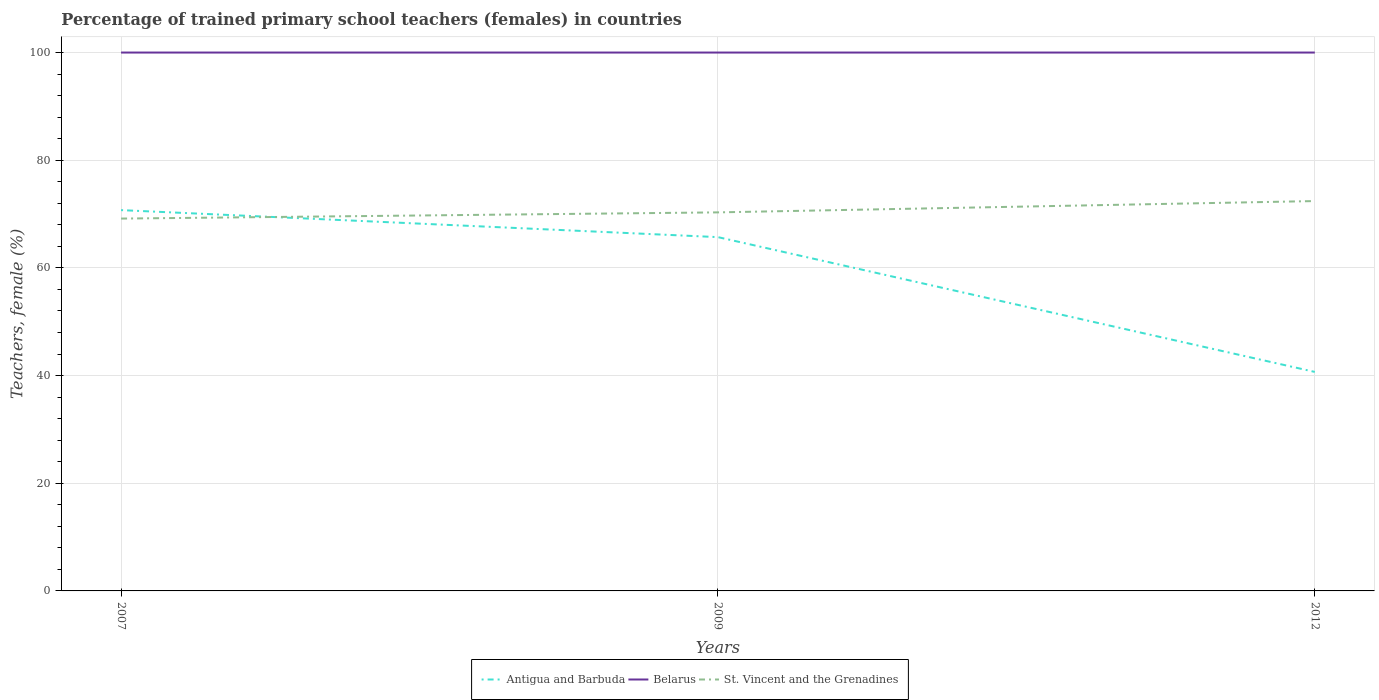How many different coloured lines are there?
Give a very brief answer. 3. Is the number of lines equal to the number of legend labels?
Make the answer very short. Yes. In which year was the percentage of trained primary school teachers (females) in Antigua and Barbuda maximum?
Provide a succinct answer. 2012. What is the total percentage of trained primary school teachers (females) in Antigua and Barbuda in the graph?
Your answer should be very brief. 5.02. What is the difference between the highest and the second highest percentage of trained primary school teachers (females) in Belarus?
Keep it short and to the point. 0. Is the percentage of trained primary school teachers (females) in St. Vincent and the Grenadines strictly greater than the percentage of trained primary school teachers (females) in Belarus over the years?
Make the answer very short. Yes. How many lines are there?
Offer a very short reply. 3. Does the graph contain grids?
Ensure brevity in your answer.  Yes. Where does the legend appear in the graph?
Provide a short and direct response. Bottom center. What is the title of the graph?
Keep it short and to the point. Percentage of trained primary school teachers (females) in countries. Does "Gabon" appear as one of the legend labels in the graph?
Your answer should be compact. No. What is the label or title of the Y-axis?
Make the answer very short. Teachers, female (%). What is the Teachers, female (%) of Antigua and Barbuda in 2007?
Your answer should be very brief. 70.73. What is the Teachers, female (%) in Belarus in 2007?
Provide a succinct answer. 100. What is the Teachers, female (%) of St. Vincent and the Grenadines in 2007?
Make the answer very short. 69.16. What is the Teachers, female (%) in Antigua and Barbuda in 2009?
Provide a short and direct response. 65.71. What is the Teachers, female (%) of St. Vincent and the Grenadines in 2009?
Give a very brief answer. 70.31. What is the Teachers, female (%) in Antigua and Barbuda in 2012?
Offer a terse response. 40.68. What is the Teachers, female (%) of Belarus in 2012?
Provide a succinct answer. 100. What is the Teachers, female (%) of St. Vincent and the Grenadines in 2012?
Your answer should be compact. 72.41. Across all years, what is the maximum Teachers, female (%) of Antigua and Barbuda?
Offer a very short reply. 70.73. Across all years, what is the maximum Teachers, female (%) of Belarus?
Offer a very short reply. 100. Across all years, what is the maximum Teachers, female (%) in St. Vincent and the Grenadines?
Your response must be concise. 72.41. Across all years, what is the minimum Teachers, female (%) of Antigua and Barbuda?
Provide a succinct answer. 40.68. Across all years, what is the minimum Teachers, female (%) in Belarus?
Keep it short and to the point. 100. Across all years, what is the minimum Teachers, female (%) of St. Vincent and the Grenadines?
Provide a succinct answer. 69.16. What is the total Teachers, female (%) of Antigua and Barbuda in the graph?
Make the answer very short. 177.12. What is the total Teachers, female (%) in Belarus in the graph?
Provide a short and direct response. 300. What is the total Teachers, female (%) of St. Vincent and the Grenadines in the graph?
Keep it short and to the point. 211.89. What is the difference between the Teachers, female (%) of Antigua and Barbuda in 2007 and that in 2009?
Your answer should be very brief. 5.02. What is the difference between the Teachers, female (%) of Belarus in 2007 and that in 2009?
Provide a succinct answer. 0. What is the difference between the Teachers, female (%) in St. Vincent and the Grenadines in 2007 and that in 2009?
Give a very brief answer. -1.15. What is the difference between the Teachers, female (%) of Antigua and Barbuda in 2007 and that in 2012?
Keep it short and to the point. 30.05. What is the difference between the Teachers, female (%) in Belarus in 2007 and that in 2012?
Offer a terse response. 0. What is the difference between the Teachers, female (%) in St. Vincent and the Grenadines in 2007 and that in 2012?
Ensure brevity in your answer.  -3.25. What is the difference between the Teachers, female (%) in Antigua and Barbuda in 2009 and that in 2012?
Offer a very short reply. 25.04. What is the difference between the Teachers, female (%) in Belarus in 2009 and that in 2012?
Make the answer very short. 0. What is the difference between the Teachers, female (%) of St. Vincent and the Grenadines in 2009 and that in 2012?
Provide a short and direct response. -2.1. What is the difference between the Teachers, female (%) of Antigua and Barbuda in 2007 and the Teachers, female (%) of Belarus in 2009?
Your answer should be compact. -29.27. What is the difference between the Teachers, female (%) of Antigua and Barbuda in 2007 and the Teachers, female (%) of St. Vincent and the Grenadines in 2009?
Give a very brief answer. 0.42. What is the difference between the Teachers, female (%) of Belarus in 2007 and the Teachers, female (%) of St. Vincent and the Grenadines in 2009?
Provide a succinct answer. 29.69. What is the difference between the Teachers, female (%) of Antigua and Barbuda in 2007 and the Teachers, female (%) of Belarus in 2012?
Give a very brief answer. -29.27. What is the difference between the Teachers, female (%) in Antigua and Barbuda in 2007 and the Teachers, female (%) in St. Vincent and the Grenadines in 2012?
Your response must be concise. -1.68. What is the difference between the Teachers, female (%) in Belarus in 2007 and the Teachers, female (%) in St. Vincent and the Grenadines in 2012?
Offer a very short reply. 27.59. What is the difference between the Teachers, female (%) of Antigua and Barbuda in 2009 and the Teachers, female (%) of Belarus in 2012?
Offer a terse response. -34.29. What is the difference between the Teachers, female (%) in Antigua and Barbuda in 2009 and the Teachers, female (%) in St. Vincent and the Grenadines in 2012?
Ensure brevity in your answer.  -6.7. What is the difference between the Teachers, female (%) of Belarus in 2009 and the Teachers, female (%) of St. Vincent and the Grenadines in 2012?
Your response must be concise. 27.59. What is the average Teachers, female (%) of Antigua and Barbuda per year?
Your answer should be compact. 59.04. What is the average Teachers, female (%) of St. Vincent and the Grenadines per year?
Ensure brevity in your answer.  70.63. In the year 2007, what is the difference between the Teachers, female (%) of Antigua and Barbuda and Teachers, female (%) of Belarus?
Ensure brevity in your answer.  -29.27. In the year 2007, what is the difference between the Teachers, female (%) in Antigua and Barbuda and Teachers, female (%) in St. Vincent and the Grenadines?
Your answer should be very brief. 1.57. In the year 2007, what is the difference between the Teachers, female (%) in Belarus and Teachers, female (%) in St. Vincent and the Grenadines?
Provide a succinct answer. 30.84. In the year 2009, what is the difference between the Teachers, female (%) of Antigua and Barbuda and Teachers, female (%) of Belarus?
Give a very brief answer. -34.29. In the year 2009, what is the difference between the Teachers, female (%) of Antigua and Barbuda and Teachers, female (%) of St. Vincent and the Grenadines?
Make the answer very short. -4.6. In the year 2009, what is the difference between the Teachers, female (%) of Belarus and Teachers, female (%) of St. Vincent and the Grenadines?
Your answer should be very brief. 29.69. In the year 2012, what is the difference between the Teachers, female (%) in Antigua and Barbuda and Teachers, female (%) in Belarus?
Make the answer very short. -59.32. In the year 2012, what is the difference between the Teachers, female (%) of Antigua and Barbuda and Teachers, female (%) of St. Vincent and the Grenadines?
Offer a very short reply. -31.74. In the year 2012, what is the difference between the Teachers, female (%) of Belarus and Teachers, female (%) of St. Vincent and the Grenadines?
Offer a terse response. 27.59. What is the ratio of the Teachers, female (%) of Antigua and Barbuda in 2007 to that in 2009?
Make the answer very short. 1.08. What is the ratio of the Teachers, female (%) in St. Vincent and the Grenadines in 2007 to that in 2009?
Keep it short and to the point. 0.98. What is the ratio of the Teachers, female (%) in Antigua and Barbuda in 2007 to that in 2012?
Provide a succinct answer. 1.74. What is the ratio of the Teachers, female (%) of Belarus in 2007 to that in 2012?
Give a very brief answer. 1. What is the ratio of the Teachers, female (%) of St. Vincent and the Grenadines in 2007 to that in 2012?
Keep it short and to the point. 0.96. What is the ratio of the Teachers, female (%) of Antigua and Barbuda in 2009 to that in 2012?
Your answer should be compact. 1.62. What is the ratio of the Teachers, female (%) in Belarus in 2009 to that in 2012?
Your response must be concise. 1. What is the ratio of the Teachers, female (%) in St. Vincent and the Grenadines in 2009 to that in 2012?
Keep it short and to the point. 0.97. What is the difference between the highest and the second highest Teachers, female (%) of Antigua and Barbuda?
Give a very brief answer. 5.02. What is the difference between the highest and the second highest Teachers, female (%) of Belarus?
Provide a short and direct response. 0. What is the difference between the highest and the second highest Teachers, female (%) in St. Vincent and the Grenadines?
Provide a short and direct response. 2.1. What is the difference between the highest and the lowest Teachers, female (%) in Antigua and Barbuda?
Your answer should be compact. 30.05. What is the difference between the highest and the lowest Teachers, female (%) in Belarus?
Make the answer very short. 0. What is the difference between the highest and the lowest Teachers, female (%) in St. Vincent and the Grenadines?
Provide a succinct answer. 3.25. 